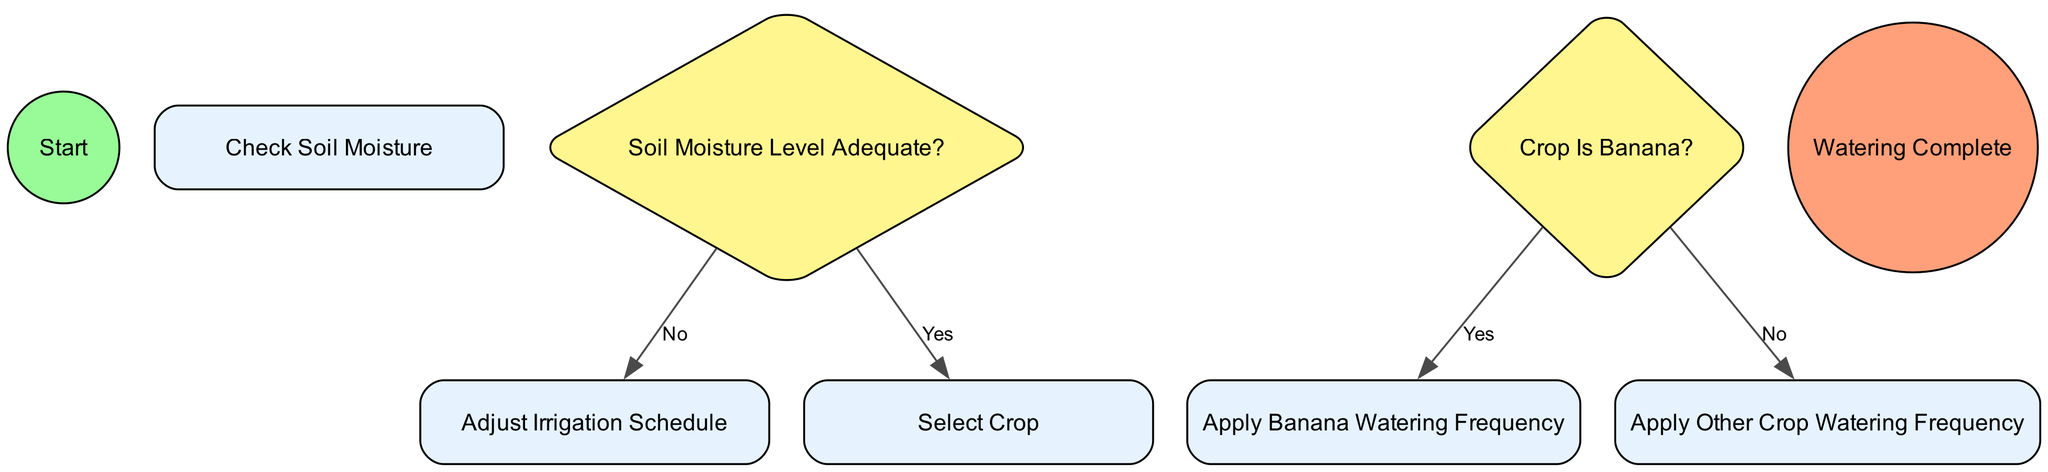What is the first action in the diagram? The diagram begins with the "Start" event, and the next action is "Check Soil Moisture." This indicates that checking soil moisture is the first step after the start.
Answer: Check Soil Moisture How many actions are present in the diagram? The diagram lists four actions: "Check Soil Moisture," "Adjust Irrigation Schedule," "Select Crop," and "Apply Banana Watering Frequency" or "Apply Other Crop Watering Frequency." Therefore, there are four actions overall.
Answer: Four What happens if the soil moisture level is adequate? If the soil moisture level is adequate, the flow leads directly to the "Select Crop" action. This indicates that the process continues with crop selection.
Answer: Select Crop What are the two watering frequency options based on the crop selection? The options for watering frequency based on the crop selection are "Apply Banana Watering Frequency" if the crop is a banana, and "Apply Other Crop Watering Frequency" if it is not. This shows that there are two distinct paths based on crop type.
Answer: Apply Banana Watering Frequency and Apply Other Crop Watering Frequency How many decisions are made in the diagram? There are two decision points in the diagram: one at "Soil Moisture Level Adequate?" and another at "Crop Is Banana?" This implies that the diagram includes two crucial decision-making stages.
Answer: Two What action follows if the soil moisture level is not adequate? If the soil moisture level is not adequate, the flow directs to the "Adjust Irrigation Schedule" action, indicating the need to revise the irrigation schedule accordingly.
Answer: Adjust Irrigation Schedule What is the final event in the diagram? The final event in the diagram is "Watering Complete," which signifies the end of the irrigation process after all actions are executed. This shows that once watering is done, the process is complete.
Answer: Watering Complete Which crop decision needs to be made after selecting the crop? The decision that needs to be made after selecting the crop is whether the selected crop is a banana. This decision point will determine the next watering frequency to apply.
Answer: Crop Is Banana What occurs between “No” response from "Soil Moisture Level Adequate?" and "Select Crop"? There is no direct path from the "No" response for the "Soil Moisture Level Adequate?" questionnaire to the "Select Crop" action; instead, it flows to "Adjust Irrigation Schedule." This indicates that the process must first adjust the irrigation schedule before considering crop selection.
Answer: Adjust Irrigation Schedule 